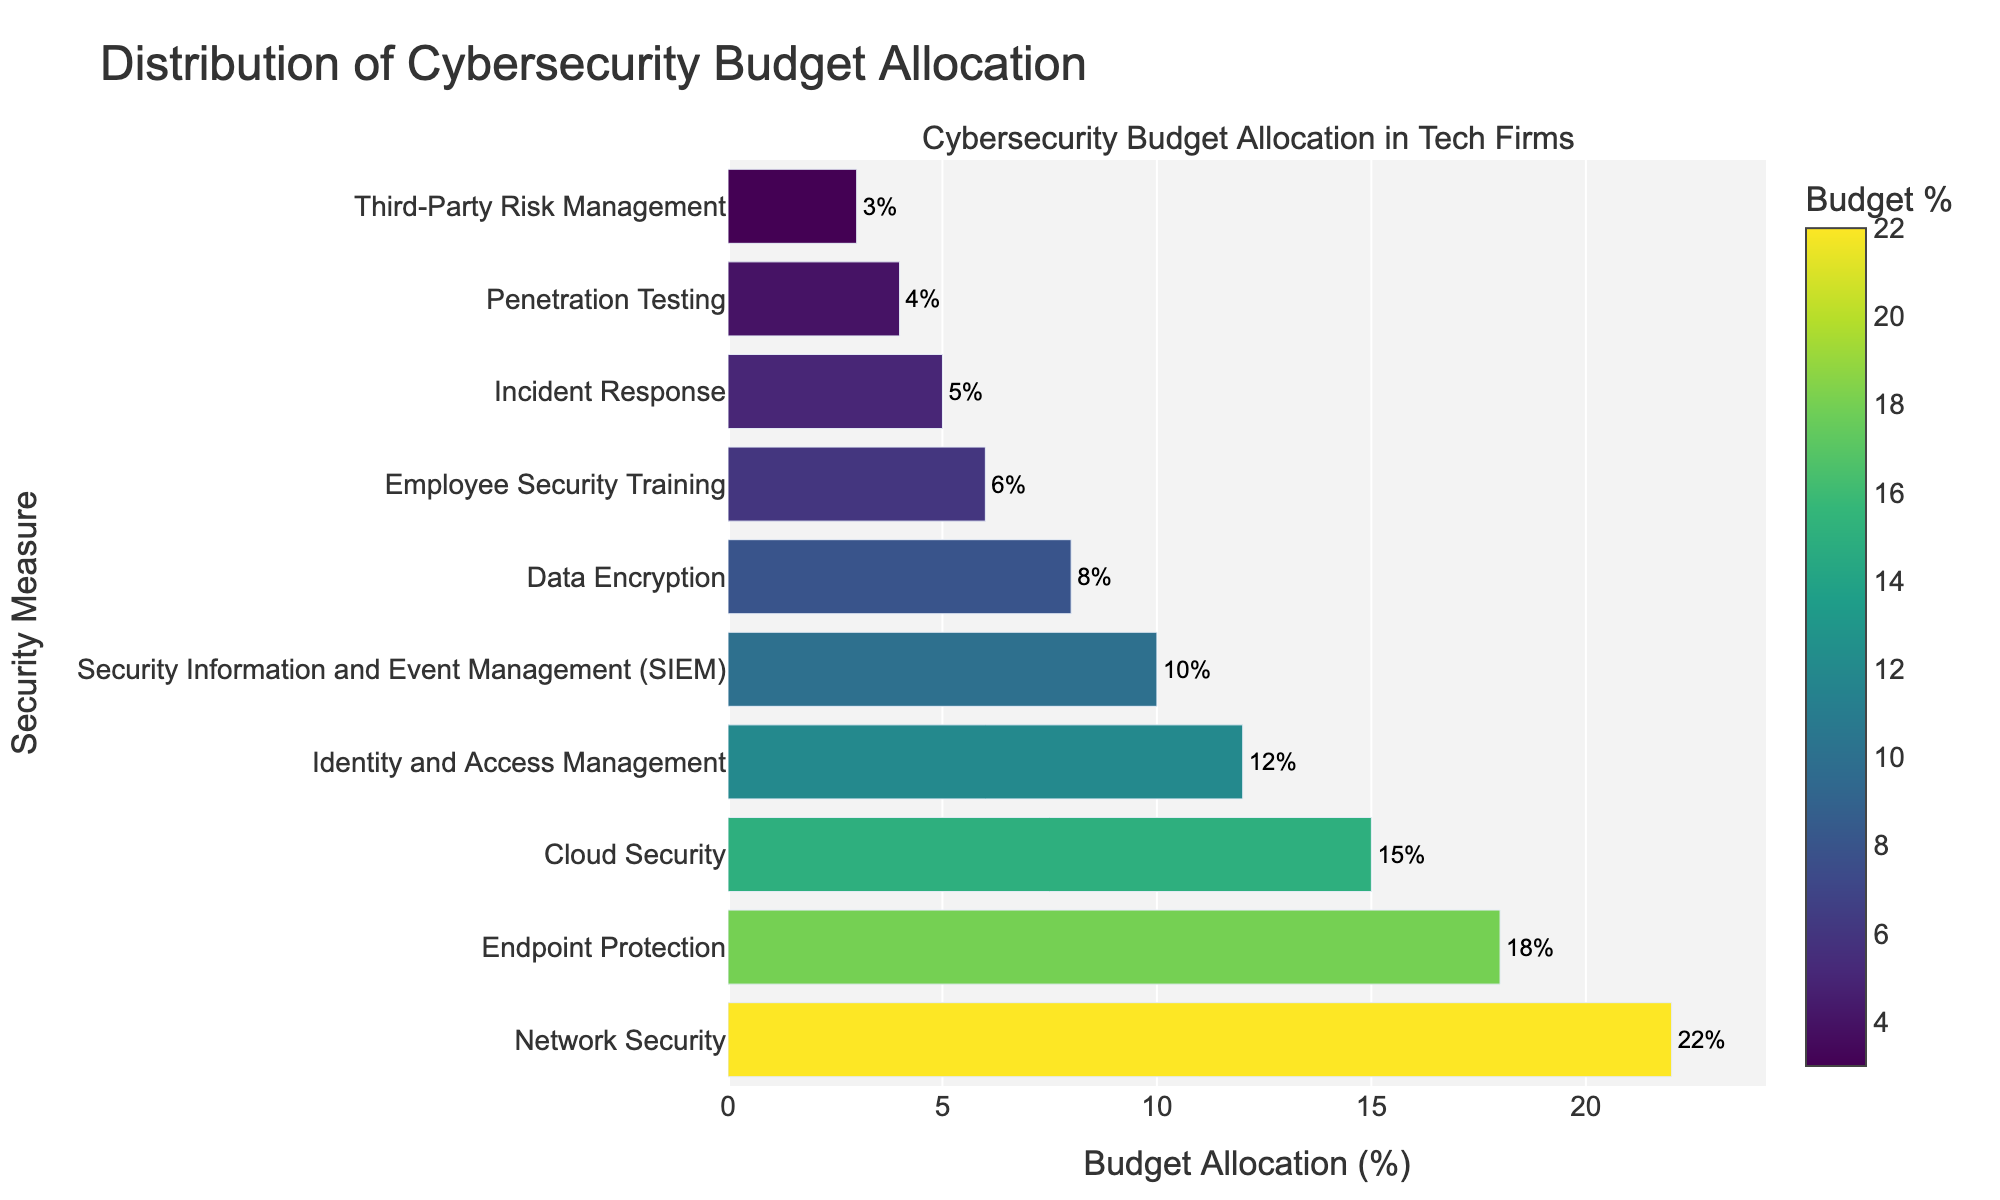Which security measure has the highest budget allocation? To identify the security measure with the highest budget allocation, look for the longest bar in the chart. The longest bar corresponds to Network Security with 22%.
Answer: Network Security Which security measure has the lowest budget allocation? To find the security measure with the lowest budget allocation, look for the shortest bar in the chart, which corresponds to Third-Party Risk Management with 3%.
Answer: Third-Party Risk Management What is the total budget allocation for Network Security and Endpoint Protection combined? Add the budget allocations for Network Security (22%) and Endpoint Protection (18%) together. 22% + 18% = 40%.
Answer: 40% How much more budget is allocated to Network Security compared to Penetration Testing? Subtract the budget allocation for Penetration Testing (4%) from Network Security (22%). 22% - 4% = 18%.
Answer: 18% What is the average budget allocation for Cloud Security, Identity and Access Management, and Security Information and Event Management (SIEM)? Add the budget allocations for Cloud Security (15%), Identity and Access Management (12%), and SIEM (10%) and then divide by 3. (15% + 12% + 10%) / 3 = 12.33%.
Answer: 12.33% How does the budget allocation for Data Encryption compare to Employee Security Training? Compare the budget allocation for Data Encryption (8%) with that of Employee Security Training (6%). Data Encryption (8%) has a 2% higher budget allocation than Employee Security Training (6%).
Answer: 2% higher What is the total budget allocation for Incident Response, Penetration Testing, and Third-Party Risk Management? Add the budget allocations for Incident Response (5%), Penetration Testing (4%), and Third-Party Risk Management (3%). 5% + 4% + 3% = 12%.
Answer: 12% How many security measures have a budget allocation greater than 10%? Count the number of bars with budget allocations greater than 10%. There are four measures: Network Security (22%), Endpoint Protection (18%), Cloud Security (15%), and Identity and Access Management (12%).
Answer: 4 Which security measure has a budget allocation closest to the median value of the datasets? The median of the dataset can be found by listing all values in ascending order and finding the middle value. Ordered values: 3%, 4%, 5%, 6%, 8%, 10%, 12%, 15%, 18%, 22%. The median value is the middle value, which is 8% for Data Encryption.
Answer: Data Encryption What is the ratio of the budget allocation of Network Security to Incident Response? Divide the budget allocation for Network Security (22%) by Incident Response (5%). 22% / 5% = 4.4.
Answer: 4.4 